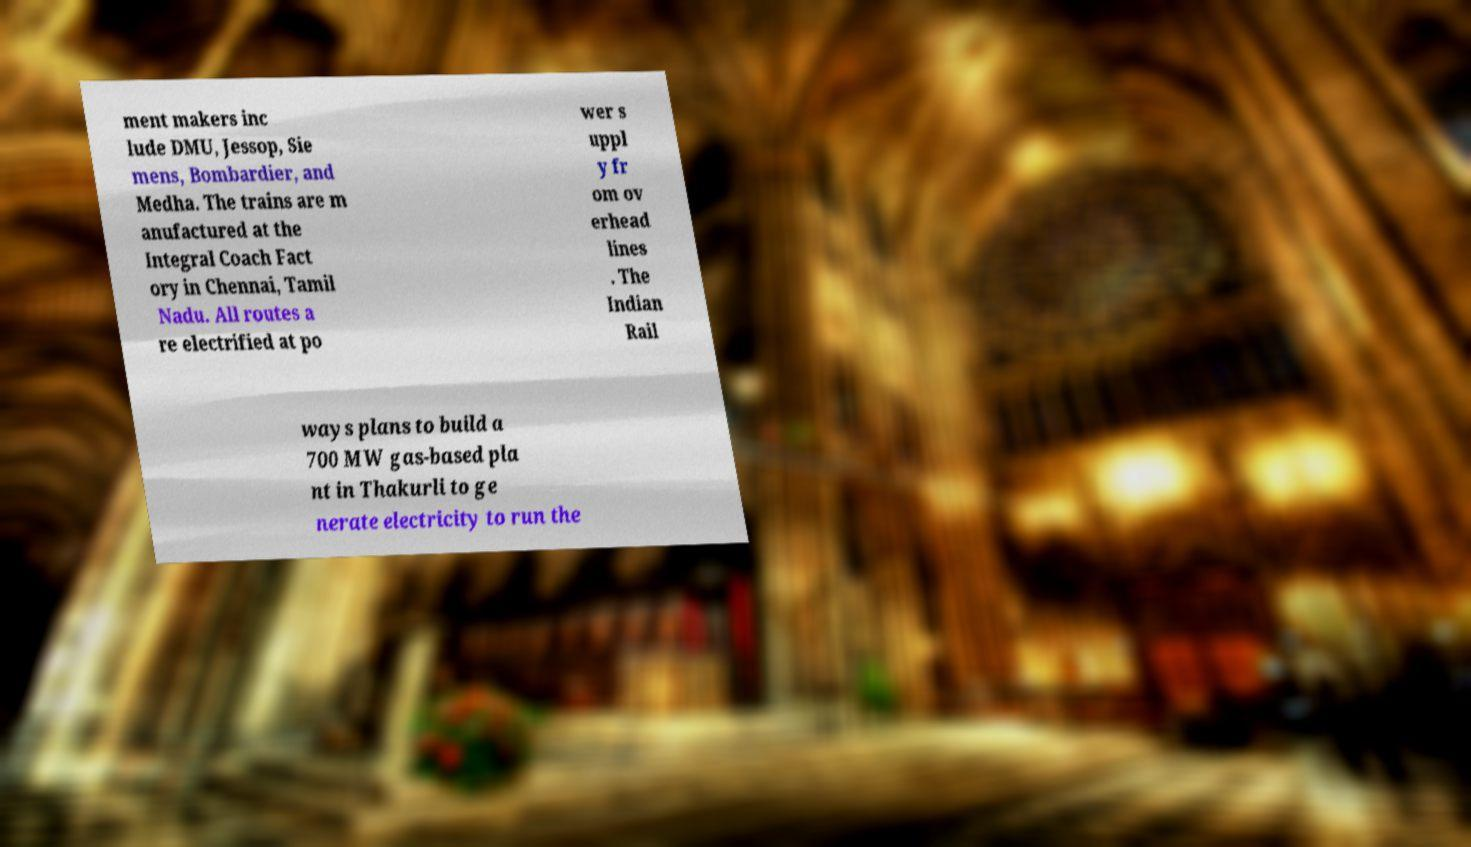Can you read and provide the text displayed in the image?This photo seems to have some interesting text. Can you extract and type it out for me? ment makers inc lude DMU, Jessop, Sie mens, Bombardier, and Medha. The trains are m anufactured at the Integral Coach Fact ory in Chennai, Tamil Nadu. All routes a re electrified at po wer s uppl y fr om ov erhead lines . The Indian Rail ways plans to build a 700 MW gas-based pla nt in Thakurli to ge nerate electricity to run the 